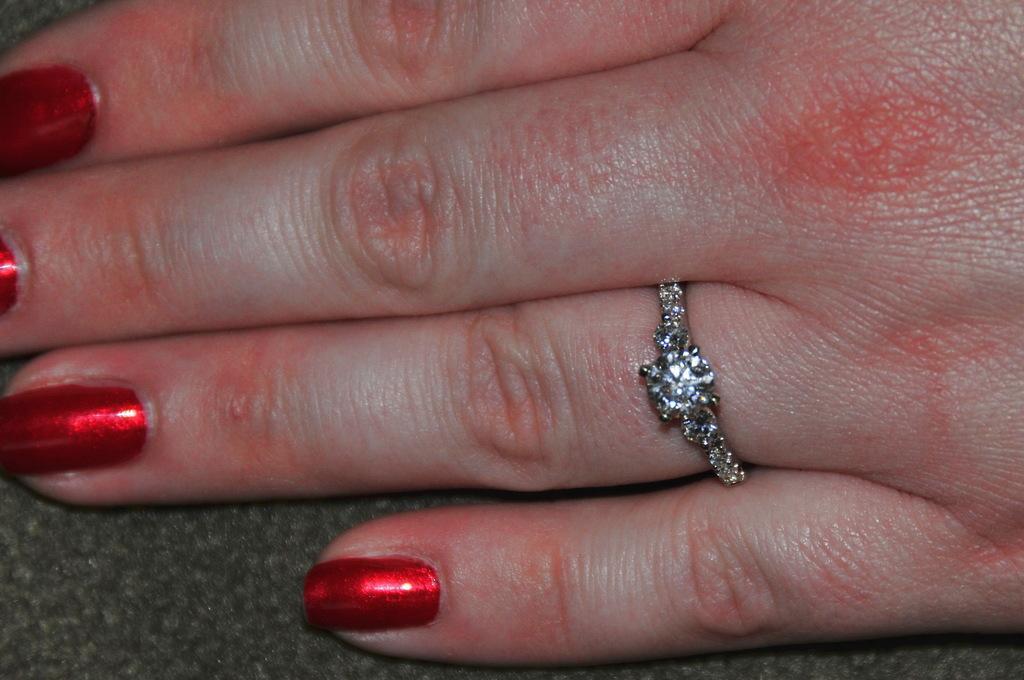Could you give a brief overview of what you see in this image? In the picture there is a nail polish present to the fingers of a person, there is a ring present. 